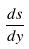<formula> <loc_0><loc_0><loc_500><loc_500>\frac { d s } { d y }</formula> 